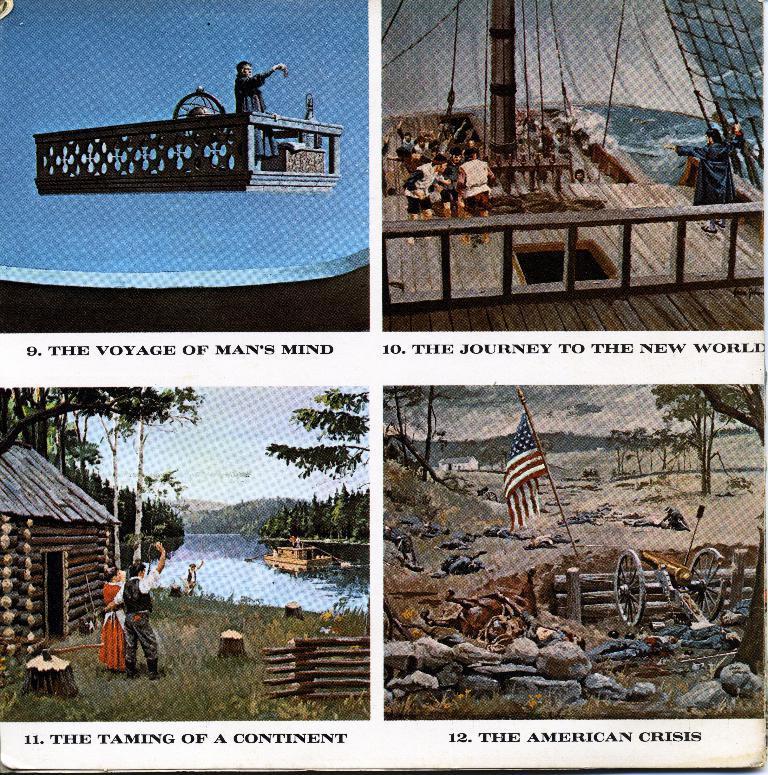Please provide a concise description of this image. This image is the collage of 4 pictures in which there are persons, there is water, there are trees, there is a flag, there are stones and there is grass on the ground, there is ship, there is a cannon and there is some text written on the image. 